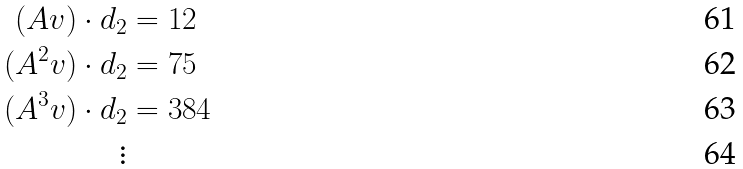Convert formula to latex. <formula><loc_0><loc_0><loc_500><loc_500>( A v ) \cdot d _ { 2 } & = 1 2 \\ ( A ^ { 2 } v ) \cdot d _ { 2 } & = 7 5 \\ ( A ^ { 3 } v ) \cdot d _ { 2 } & = 3 8 4 \\ \vdots</formula> 